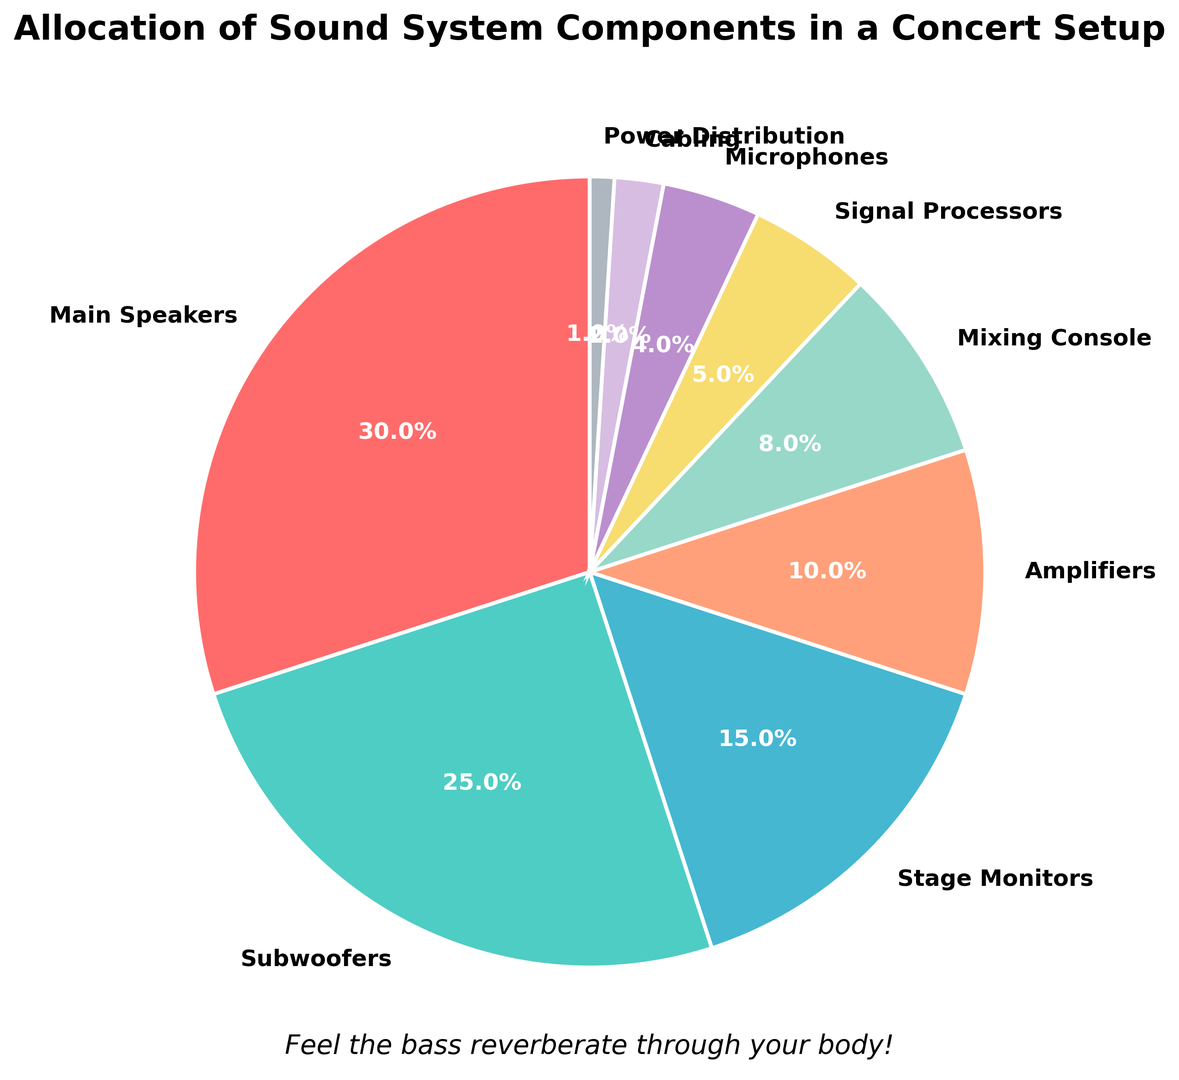What's the total percentage allocated to Main Speakers and Subwoofers? The percentage for Main Speakers is 30%, and for Subwoofers, it is 25%. Adding them together: 30% + 25% = 55%
Answer: 55% Which component has the smallest allocation? Looking at the figure, the smallest segment is for Power Distribution, which is 1%
Answer: Power Distribution How much greater is the percentage for Amplifiers compared to Signal Processors? The percentage for Amplifiers is 10%, and for Signal Processors, it is 5%. The difference is 10% - 5% = 5%
Answer: 5% Which two components have a combined allocation equal to the percentage for Subwoofers? Comparing the percentages, Subwoofers are 25%. Stage Monitors (15%) and Signal Processors (5%) combined (15% + 5% = 20%) do not meet it. Similarly, other combinations: Amplifiers (10%) + Mixing Console (8%) = 18%, Microphones (4%) + Cabling (2%) = 6%, and other combinations, don't work. No exact combination matches 25%
Answer: No pair Which component is labeled with a teal color and what percentage does it represent? The teal color is used for Subwoofers, which are labeled with 25%
Answer: Subwoofers, 25% Is the allocation percentage for Mixing Console greater than that of Signal Processors? The percentage for Mixing Console is 8%, while for Signal Processors, it is 5%. Since 8% > 5%, Yes
Answer: Yes What is the average percentage allocation for Microphones, Cabling, and Power Distribution? The percentages for Microphones, Cabling, and Power Distribution are 4%, 2%, and 1% respectively. Sum them: 4% + 2% + 1% = 7%. The average is 7% / 3 ≈ 2.3%
Answer: ≈ 2.3% How much more is allocated to Main Speakers than to Stage Monitors? The percentage for Main Speakers is 30%, and for Stage Monitors, it is 15%. The difference is 30% - 15% = 15%
Answer: 15% What proportion of the sound system setup is allocated to items other than Main Speakers, Subwoofers, and Stage Monitors? Subtract the combined percentages of Main Speakers, Subwoofers, and Stage Monitors from 100%. 30% + 25% + 15% = 70%. Thus, 100% - 70% = 30%
Answer: 30% If the total budget for the sound system is $100,000, how much money is allocated to Cabling? Cabling is allocated 2%. To find the amount, calculate 2% of $100,000: (2 / 100) * $100,000 = $2,000
Answer: $2,000 